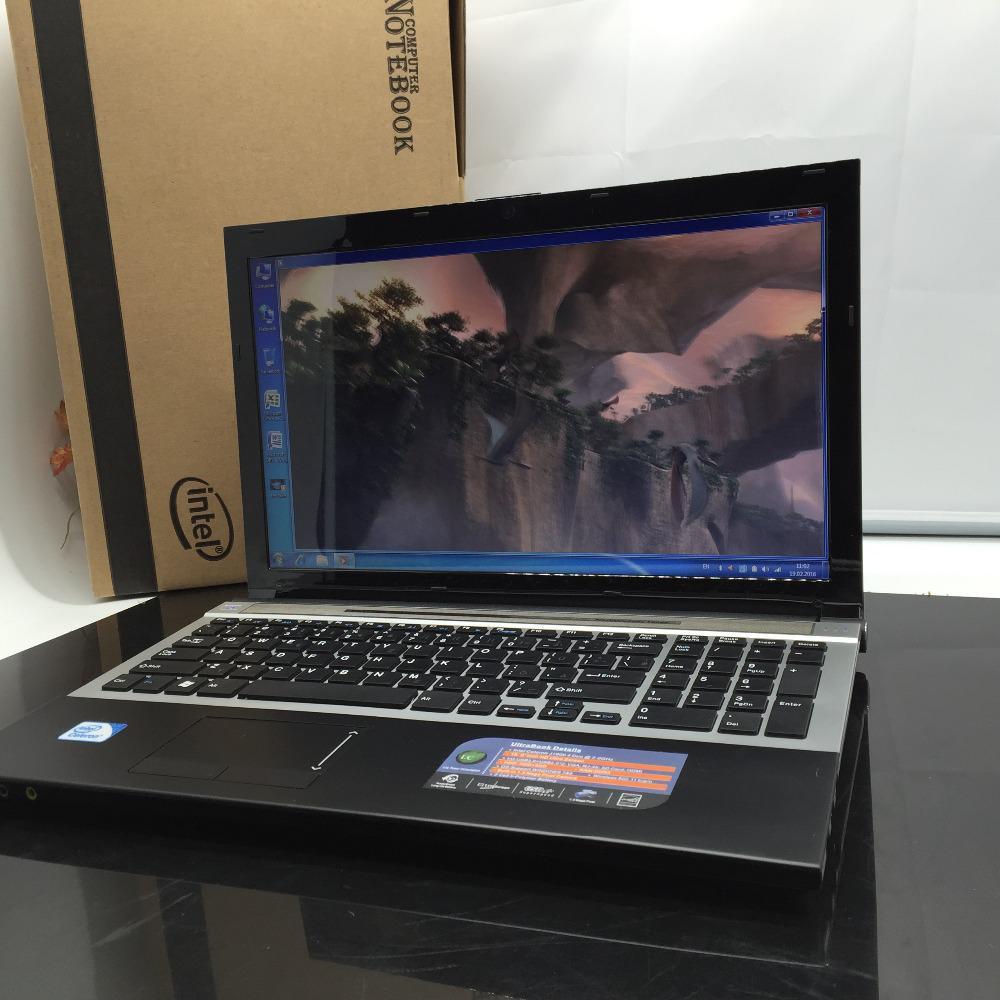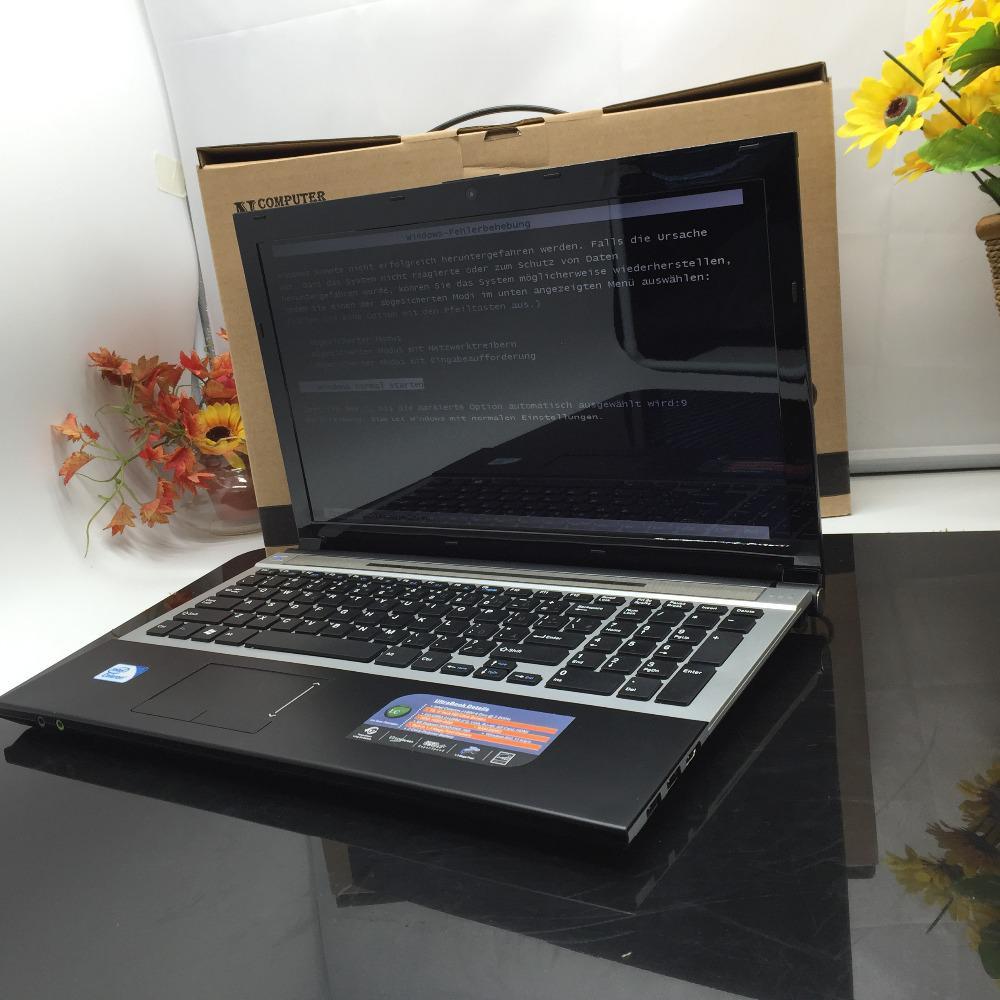The first image is the image on the left, the second image is the image on the right. Assess this claim about the two images: "In one image, the laptop screen displays a created sweeping scene.". Correct or not? Answer yes or no. Yes. The first image is the image on the left, the second image is the image on the right. For the images displayed, is the sentence "At least one computer has a blue graphic background on the screen." factually correct? Answer yes or no. No. 